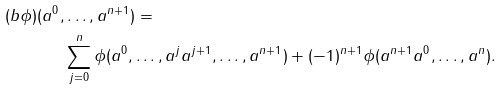<formula> <loc_0><loc_0><loc_500><loc_500>( b \phi ) ( a ^ { 0 } , & \dots , a ^ { n + 1 } ) = \\ & \sum _ { j = 0 } ^ { n } \phi ( a ^ { 0 } , \dots , a ^ { j } a ^ { j + 1 } , \dots , a ^ { n + 1 } ) + ( - 1 ) ^ { n + 1 } \phi ( a ^ { n + 1 } a ^ { 0 } , \dots , a ^ { n } ) .</formula> 